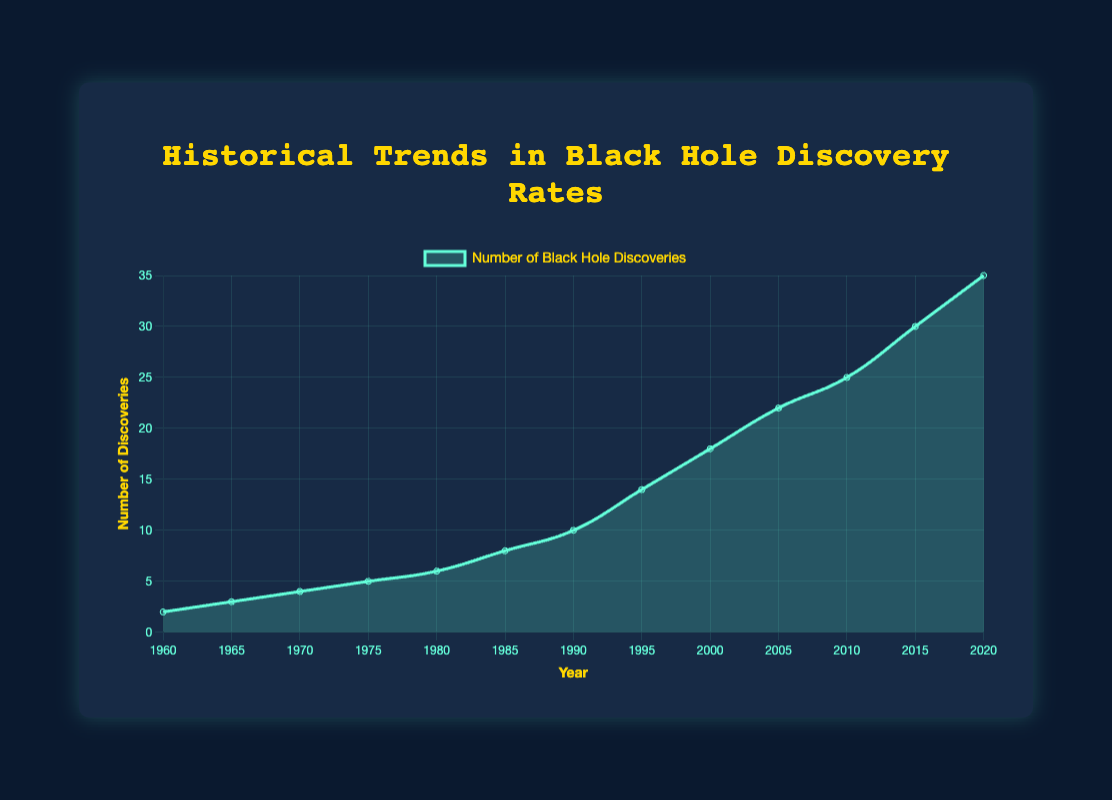What's the title of the figure? The title is located at the top of the figure in a larger font.
Answer: Historical Trends in Black Hole Discovery Rates What are the units of the x-axis and y-axis? The x-axis is labeled "Year," representing time, and the y-axis is labeled "Number of Discoveries," representing the count of black hole discoveries.
Answer: Years and Number of Discoveries How many total black hole discoveries were made by the year 2000? Sum the number of discoveries from 1960 to 2000: 2 + 3 + 4 + 5 + 6 + 8 + 10 + 14 + 18 = 70
Answer: 70 In which decade did the number of black hole discoveries increase the most? Calculate the difference in discoveries between the beginning and the end of each decade. The largest increase occurs between 1990 and 2000 (14 to 18).
Answer: 1990s Compare the number of discoveries in 1980 and 2020. By how much did the discoveries increase? Subtract the number of discoveries in 1980 from that in 2020: 35 - 6 = 29
Answer: 29 What was the average number of black hole discoveries per year between 1960 and 2020? Total discoveries from 1960 to 2020 is 2 + 3 + 4 + 5 + 6 + 8 + 10 + 14 + 18 + 22 + 25 + 30 + 35 = 182. There are 13 years in this range. 182/13 = 14
Answer: 14 Between which years did the number of discoveries grow faster, 1985-2000 or 2000-2015? Calculate the rate of increase for both intervals: 
Period 1985-2000: (18-8)/(2000-1985) = 10/15 = 0.67
Period 2000-2015: (30-18)/(2015-2000) = 12/15 = 0.8
The higher rate is from 2000 to 2015.
Answer: 2000-2015 What is the overall trend in the number of black hole discoveries over time? The general pattern shown by the area chart indicates a steady increase in the number of black hole discoveries over time.
Answer: Increasing trend During which five-year period did the discoveries increase from 14 to 22? Check the provided data to see the increments within five-year periods. The period between 1995 (14 discoveries) and 2000 (18 discoveries) is incorrect, thus it must be between 2000 (18) and 2005 (22).
Answer: 2000-2005 